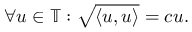<formula> <loc_0><loc_0><loc_500><loc_500>\forall u \in \mathbb { T } \colon \sqrt { \langle u , u \rangle } = c u .</formula> 